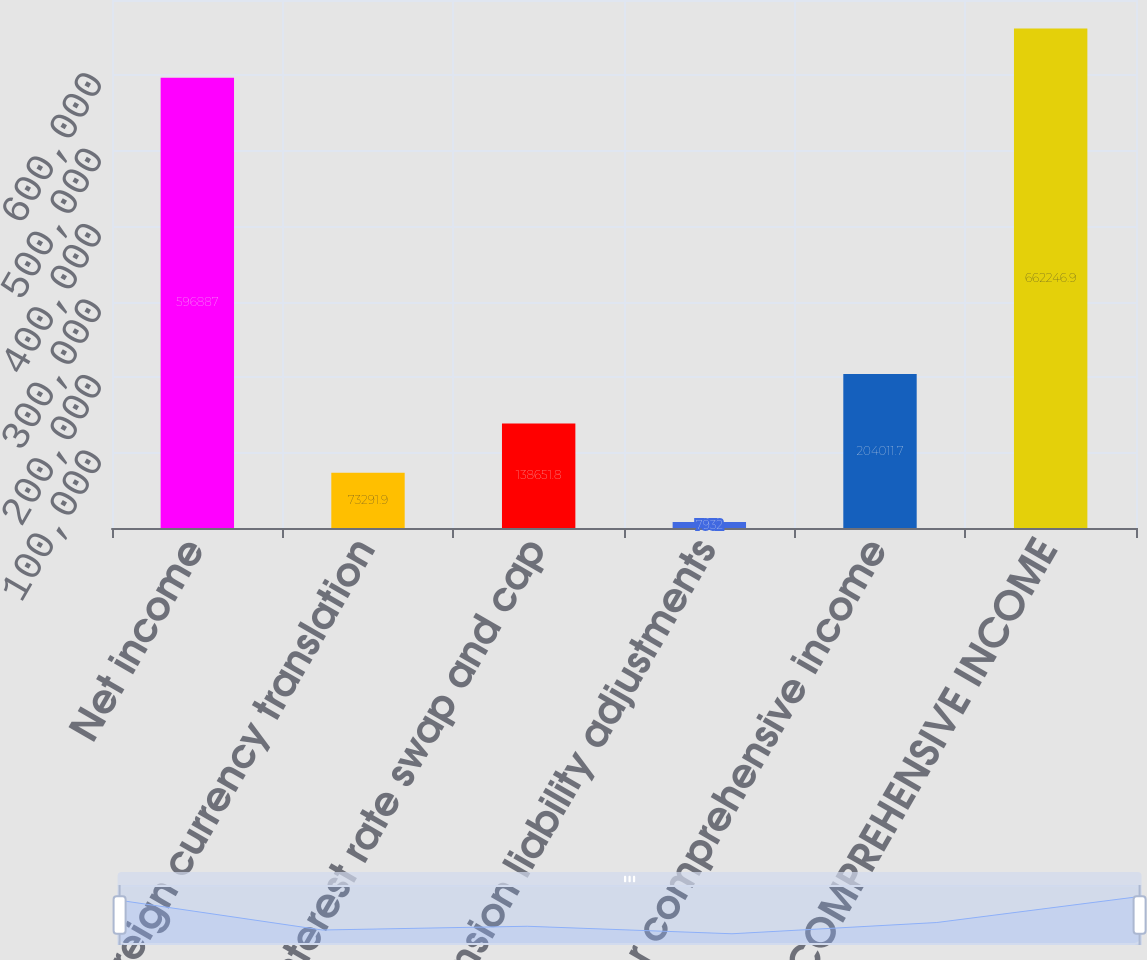Convert chart to OTSL. <chart><loc_0><loc_0><loc_500><loc_500><bar_chart><fcel>Net income<fcel>Foreign currency translation<fcel>Interest rate swap and cap<fcel>Pension liability adjustments<fcel>Other comprehensive income<fcel>TOTAL COMPREHENSIVE INCOME<nl><fcel>596887<fcel>73291.9<fcel>138652<fcel>7932<fcel>204012<fcel>662247<nl></chart> 